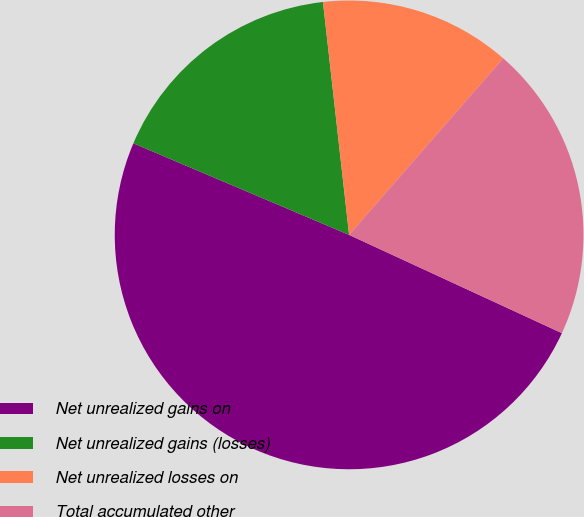<chart> <loc_0><loc_0><loc_500><loc_500><pie_chart><fcel>Net unrealized gains on<fcel>Net unrealized gains (losses)<fcel>Net unrealized losses on<fcel>Total accumulated other<nl><fcel>49.5%<fcel>16.83%<fcel>13.2%<fcel>20.46%<nl></chart> 